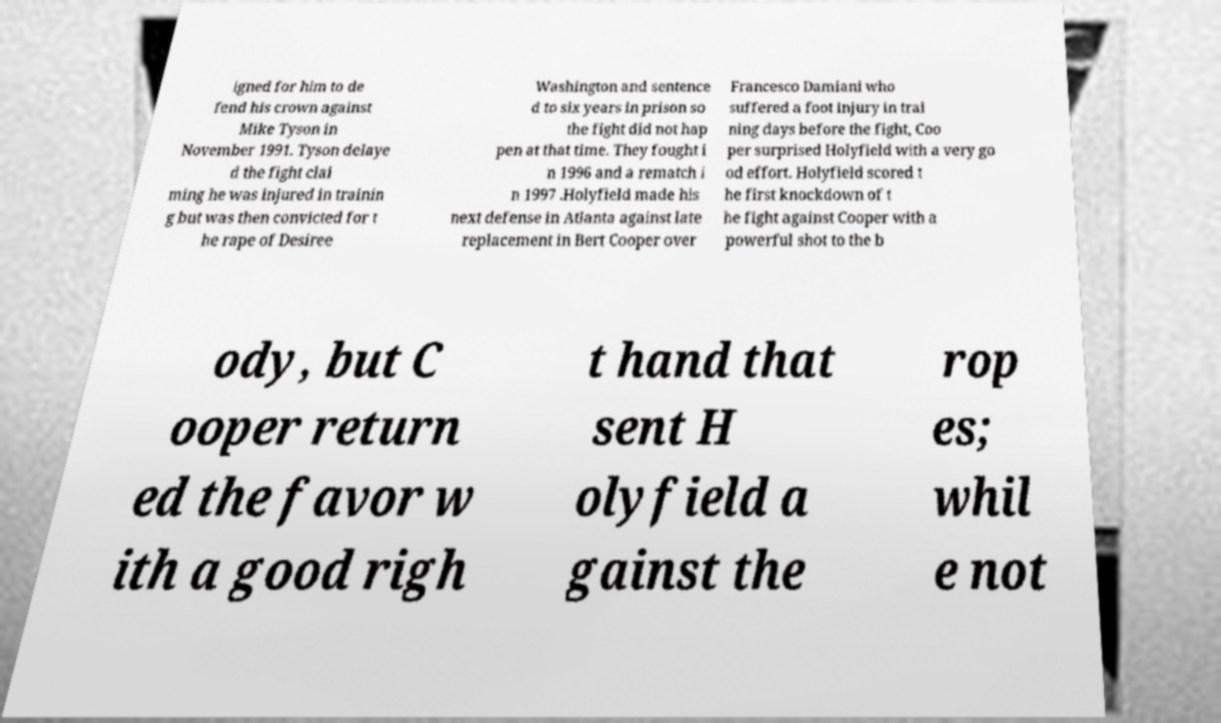For documentation purposes, I need the text within this image transcribed. Could you provide that? igned for him to de fend his crown against Mike Tyson in November 1991. Tyson delaye d the fight clai ming he was injured in trainin g but was then convicted for t he rape of Desiree Washington and sentence d to six years in prison so the fight did not hap pen at that time. They fought i n 1996 and a rematch i n 1997 .Holyfield made his next defense in Atlanta against late replacement in Bert Cooper over Francesco Damiani who suffered a foot injury in trai ning days before the fight, Coo per surprised Holyfield with a very go od effort. Holyfield scored t he first knockdown of t he fight against Cooper with a powerful shot to the b ody, but C ooper return ed the favor w ith a good righ t hand that sent H olyfield a gainst the rop es; whil e not 